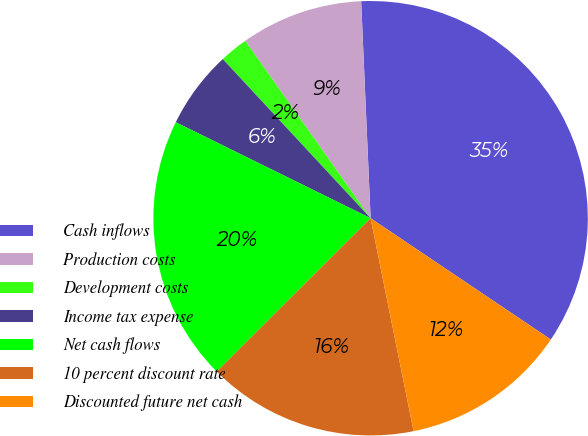<chart> <loc_0><loc_0><loc_500><loc_500><pie_chart><fcel>Cash inflows<fcel>Production costs<fcel>Development costs<fcel>Income tax expense<fcel>Net cash flows<fcel>10 percent discount rate<fcel>Discounted future net cash<nl><fcel>35.12%<fcel>9.1%<fcel>2.12%<fcel>5.8%<fcel>19.76%<fcel>15.7%<fcel>12.4%<nl></chart> 